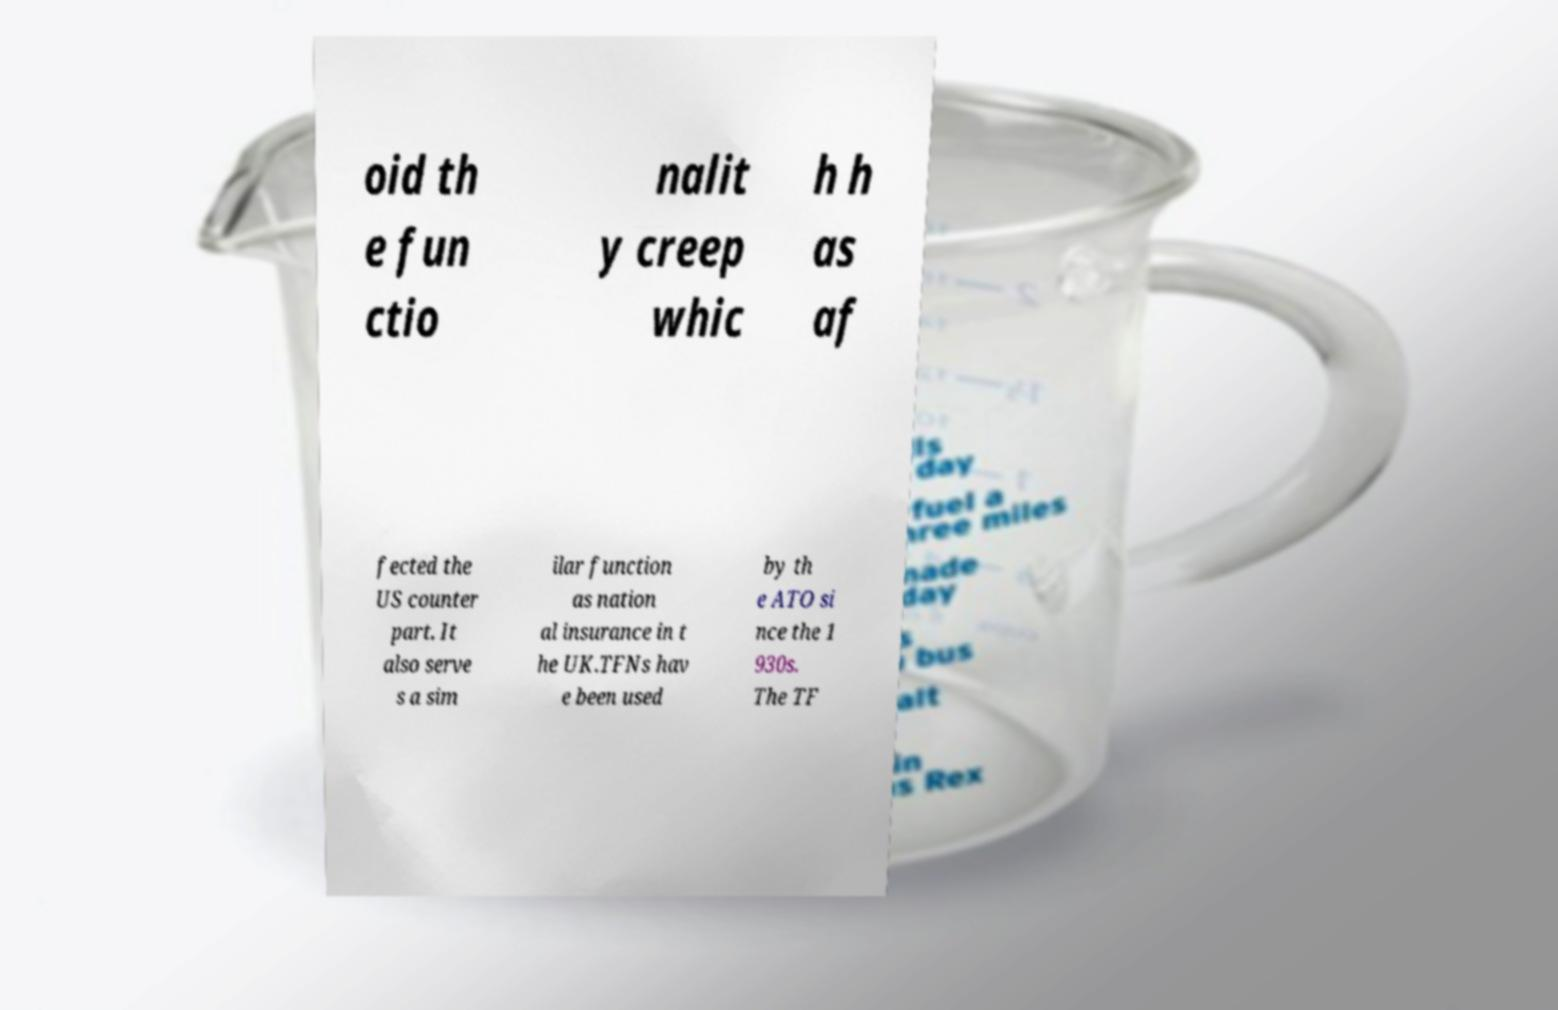I need the written content from this picture converted into text. Can you do that? oid th e fun ctio nalit y creep whic h h as af fected the US counter part. It also serve s a sim ilar function as nation al insurance in t he UK.TFNs hav e been used by th e ATO si nce the 1 930s. The TF 